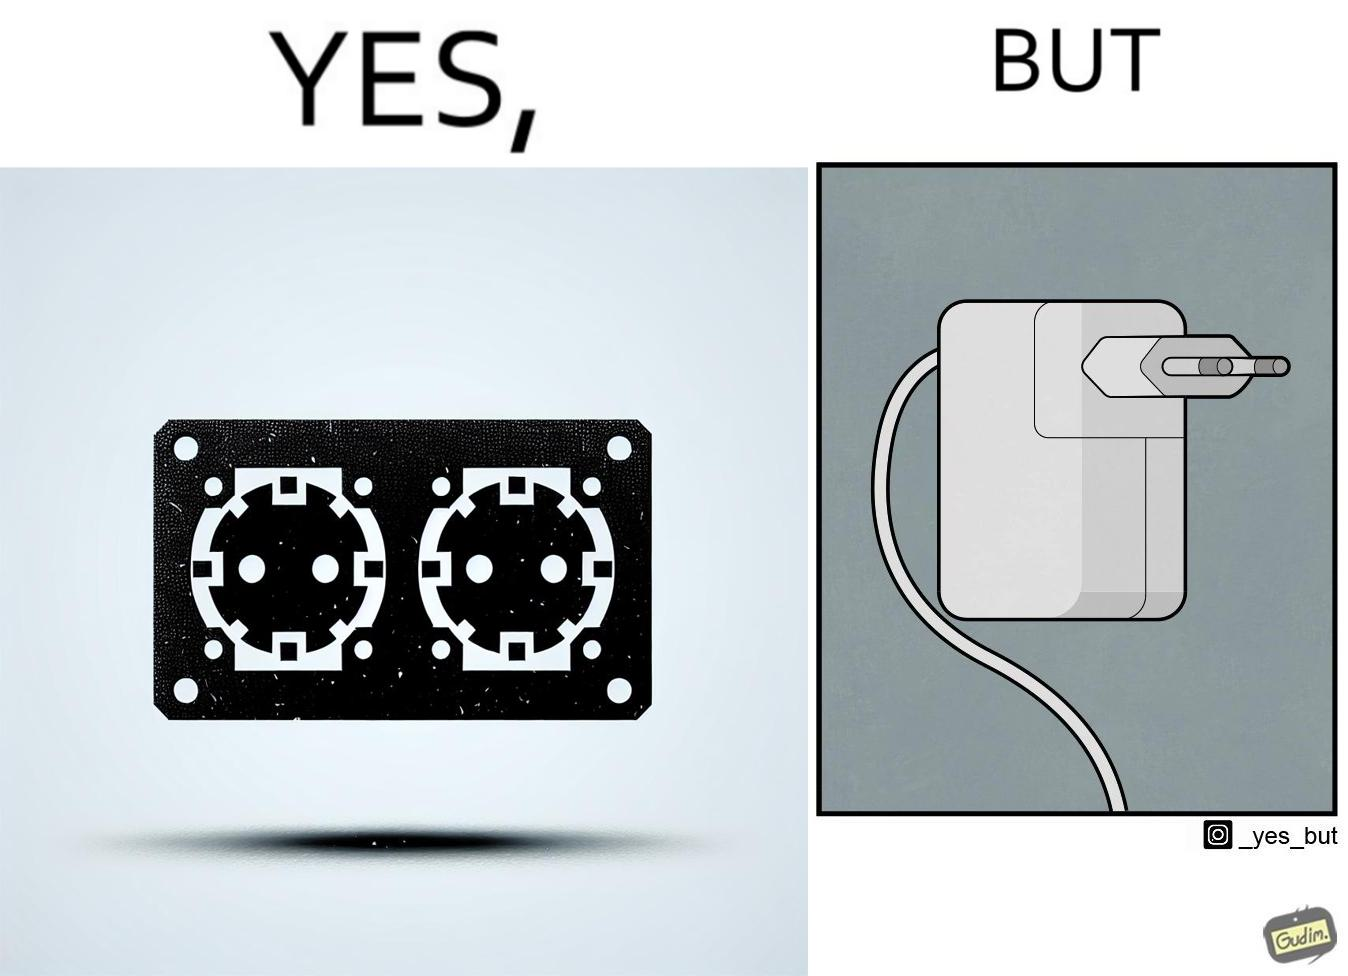Does this image contain satire or humor? Yes, this image is satirical. 